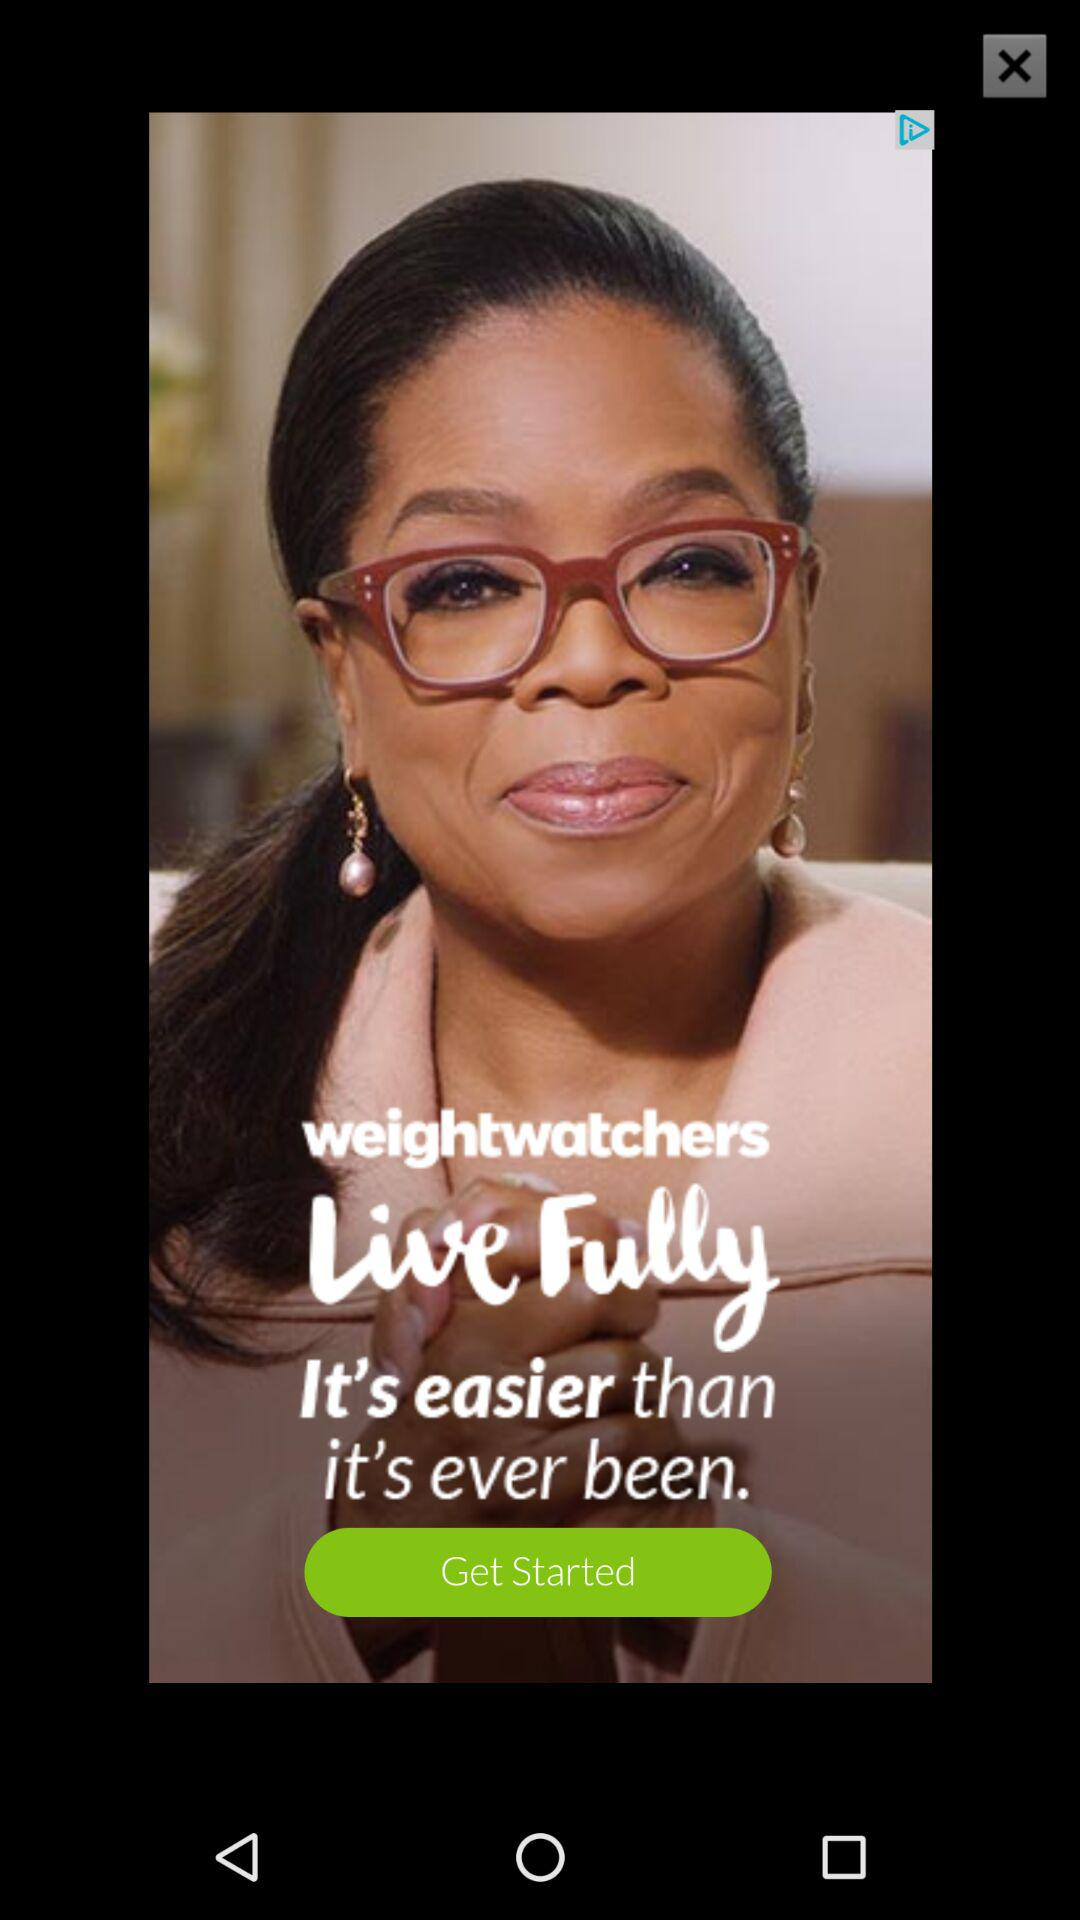What is the name of the application? The name of the application is "weightwatchers". 